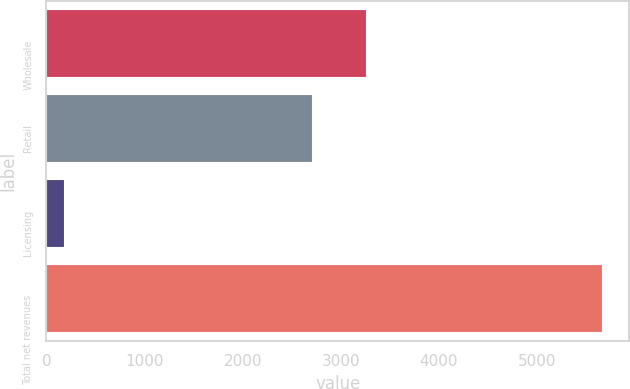<chart> <loc_0><loc_0><loc_500><loc_500><bar_chart><fcel>Wholesale<fcel>Retail<fcel>Licensing<fcel>Total net revenues<nl><fcel>3252.38<fcel>2704.2<fcel>178.5<fcel>5660.3<nl></chart> 